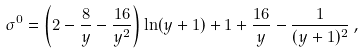Convert formula to latex. <formula><loc_0><loc_0><loc_500><loc_500>\sigma ^ { 0 } = \left ( 2 - \frac { 8 } { y } - \frac { 1 6 } { y ^ { 2 } } \right ) \ln ( y + 1 ) + 1 + \frac { 1 6 } { y } - \frac { 1 } { ( y + 1 ) ^ { 2 } } \, ,</formula> 